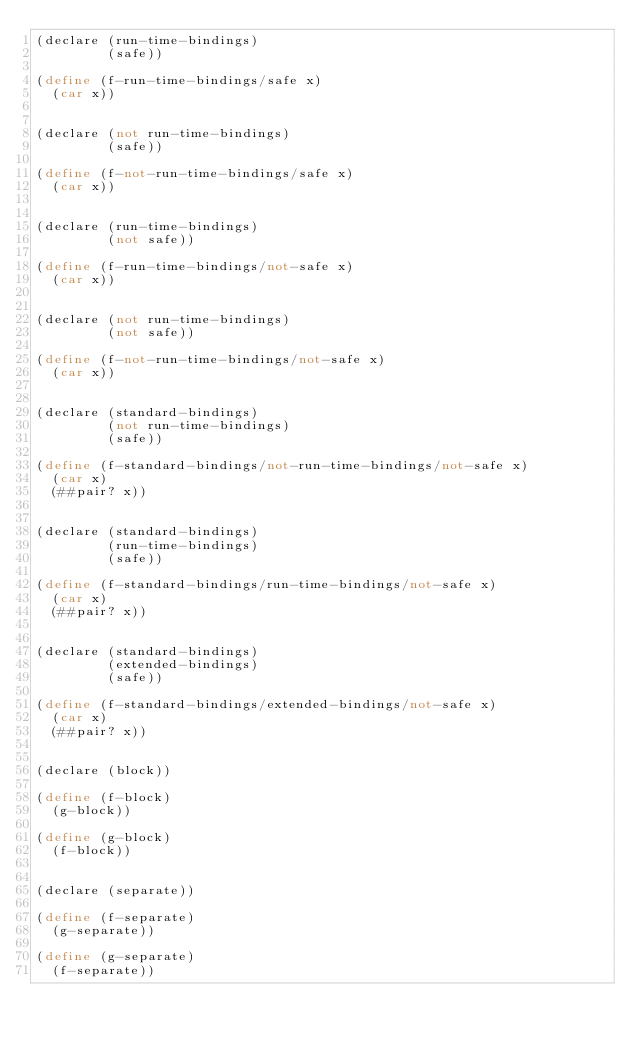<code> <loc_0><loc_0><loc_500><loc_500><_Scheme_>(declare (run-time-bindings)
         (safe))

(define (f-run-time-bindings/safe x)
  (car x))


(declare (not run-time-bindings)
         (safe))

(define (f-not-run-time-bindings/safe x)
  (car x))


(declare (run-time-bindings)
         (not safe))

(define (f-run-time-bindings/not-safe x)
  (car x))


(declare (not run-time-bindings)
         (not safe))

(define (f-not-run-time-bindings/not-safe x)
  (car x))


(declare (standard-bindings)
         (not run-time-bindings)
         (safe))

(define (f-standard-bindings/not-run-time-bindings/not-safe x)
  (car x)
  (##pair? x))


(declare (standard-bindings)
         (run-time-bindings)
         (safe))

(define (f-standard-bindings/run-time-bindings/not-safe x)
  (car x)
  (##pair? x))


(declare (standard-bindings)
         (extended-bindings)
         (safe))

(define (f-standard-bindings/extended-bindings/not-safe x)
  (car x)
  (##pair? x))


(declare (block))

(define (f-block)
  (g-block))

(define (g-block)
  (f-block))


(declare (separate))

(define (f-separate)
  (g-separate))

(define (g-separate)
  (f-separate))
</code> 